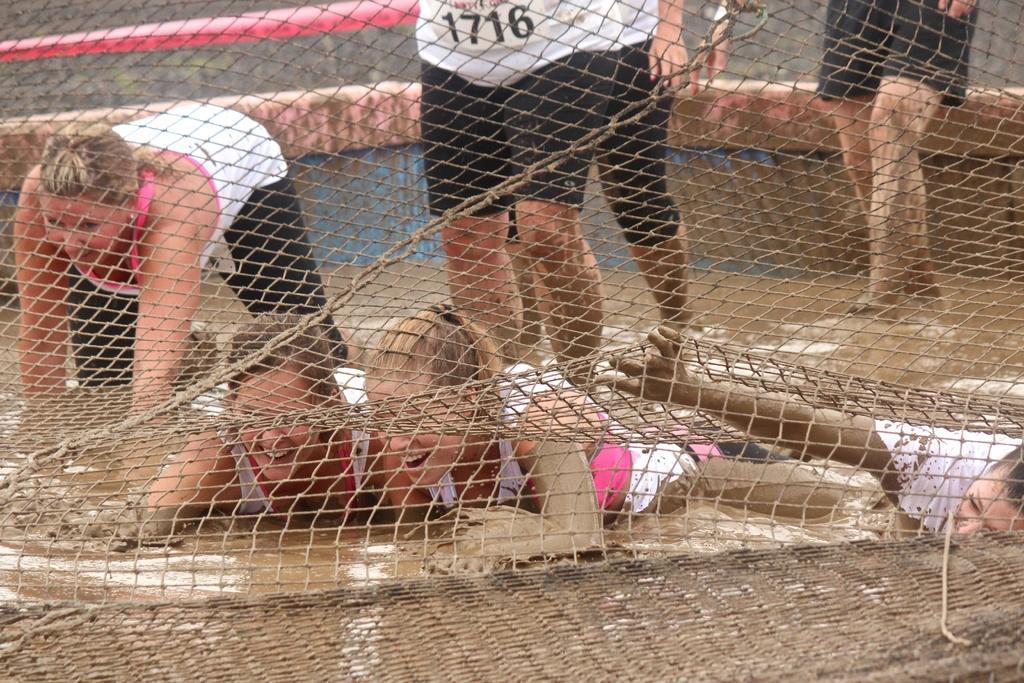Could you give a brief overview of what you see in this image? In the image we can see there are people wearing clothes, they are standing and some of them are lying in the mud. This is a net and this is a mud. 